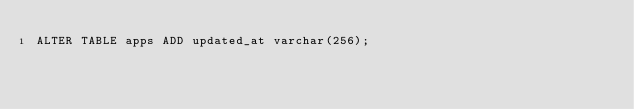<code> <loc_0><loc_0><loc_500><loc_500><_SQL_>ALTER TABLE apps ADD updated_at varchar(256);
</code> 